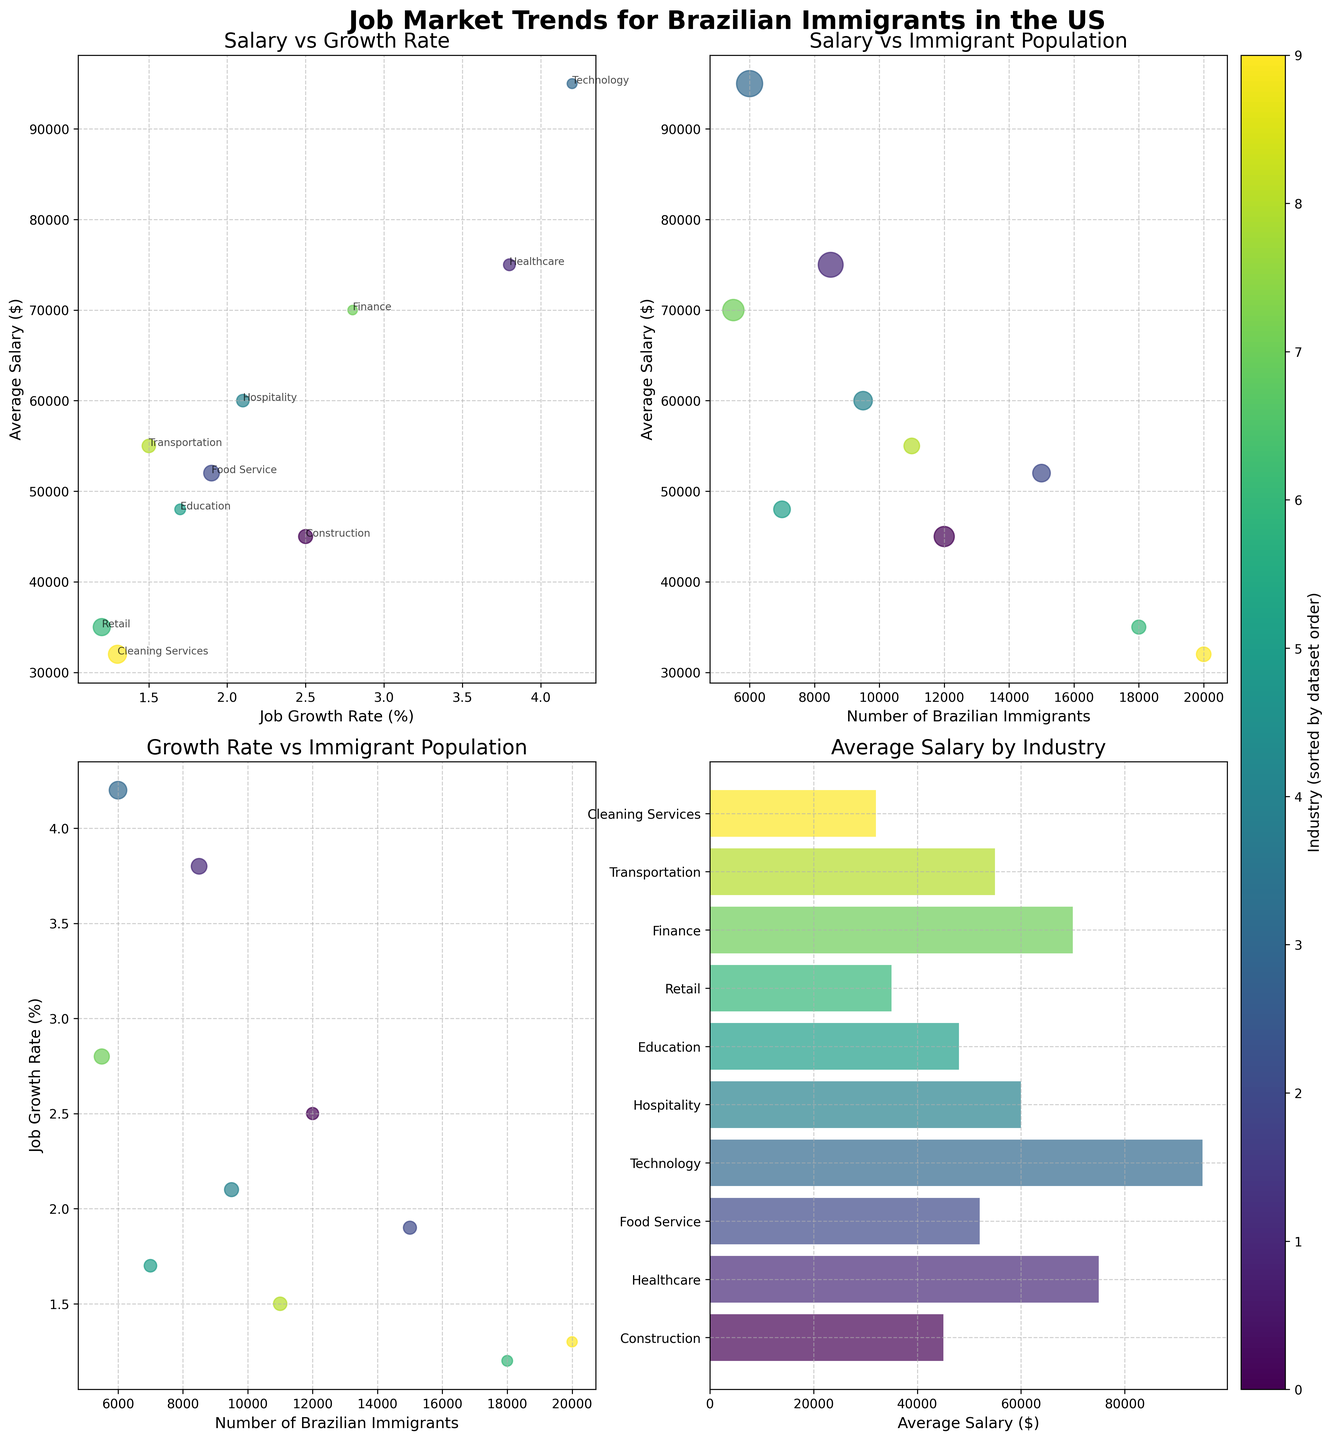What's the overall trend between average salary and job growth rate? There is a positive correlation between average salary and job growth rate in the top-left scatter plot. Higher job growth rates generally correspond to higher average salaries.
Answer: Positive correlation Which industry has the highest average salary? In the bar plot (bottom-right), the Technology industry has the highest average salary at $95,000.
Answer: Technology How does the number of Brazilian immigrants vary with job growth rate? In the bottom-left scatter plot, there's a positive trend where higher job growth rates generally correspond to a higher number of Brazilian immigrants, but with some variability.
Answer: Positive trend What is the average salary of Truck Drivers compared to Registered Nurses? From the bottom-right bar plot, Truck Drivers have an average salary of $55,000, and Registered Nurses have an average salary of $75,000. Therefore, Registered Nurses earn more.
Answer: Registered Nurses earn more How many Brazilian immigrants work in the Food Service industry? In the bottom-left scatter plot and the scatter plot on the top-right, the number of Brazilian immigrants in the Food Service industry is shown as 15,000.
Answer: 15,000 Which occupation has the lowest job growth rate and what is its corresponding average salary? The lowest job growth rate is for Sales Associates in the Retail industry at 1.2%, with an average salary of $35,000, according to the top-left scatter plot.
Answer: Sales Associates, $35,000 Which industry has the highest number of Brazilian immigrants, and what is its average salary? The Cleaning Services industry has the highest number of Brazilian immigrants (20,000) with an average salary of $32,000, as seen in the middle scatter plots and the bar plot.
Answer: Cleaning Services, $32,000 Is there a correlation between the number of Brazilian immigrants and average salary? The top-right scatter plot shows no clear correlation between the number of Brazilian immigrants and average salary, indicating that these variables are not strongly related.
Answer: No clear correlation What is the spread of job growth rates across different industries? Job growth rates in the bottom-left scatter plot range from 1.2% (Retail) to 4.2% (Technology), showing a wide spread across industries.
Answer: 1.2% to 4.2% Which industry has a relatively high job growth rate but a lower-than-average salary? The Healthcare industry, with a job growth rate of 3.8% and an average salary of $75,000, fits this description according to the plots.
Answer: Healthcare 